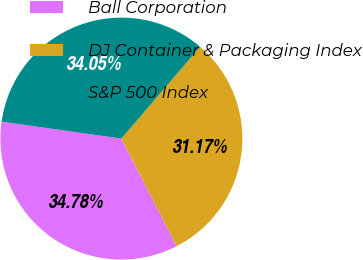Convert chart. <chart><loc_0><loc_0><loc_500><loc_500><pie_chart><fcel>Ball Corporation<fcel>DJ Container & Packaging Index<fcel>S&P 500 Index<nl><fcel>34.78%<fcel>31.17%<fcel>34.05%<nl></chart> 